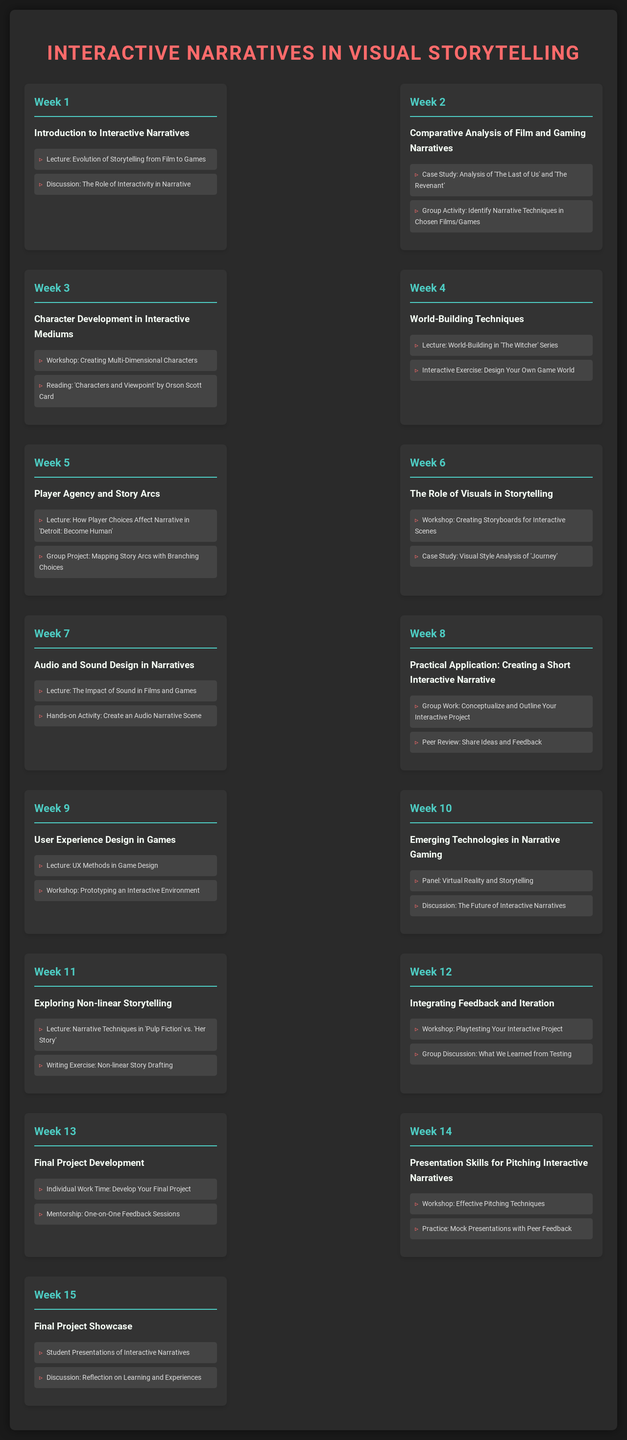What is the title of the course? The title of the course is presented prominently at the top of the document.
Answer: Interactive Narratives in Visual Storytelling How many weeks does the workshop span? The workshop schedule lists activities for fifteen weeks, signifying the total duration.
Answer: 15 What concept is covered in Week 5? The specific topic outlined for Week 5 is focused on player choices affecting the narrative.
Answer: Player Agency and Story Arcs Which week includes a case study of 'Journey'? The specific week dedicated to studying the visual style of 'Journey' is noted within the schedule.
Answer: Week 6 What type of exercise is featured in Week 11? The writing exercise highlighted encourages participants to draft stories with non-linear structures.
Answer: Non-linear Story Drafting How many workshops are scheduled throughout the course? By reviewing the weekly topics, the total number of workshops can be counted and summarized.
Answer: 5 What is the focus of Week 13? This week emphasizes individual project development and provided mentorship opportunities.
Answer: Final Project Development What is the final activity listed for the course? The last activity showcases student presentations, marking the conclusion of the course.
Answer: Final Project Showcase Which week focuses on sound design in narratives? The week dedicated to understanding audio elements in storytelling is indicated.
Answer: Week 7 